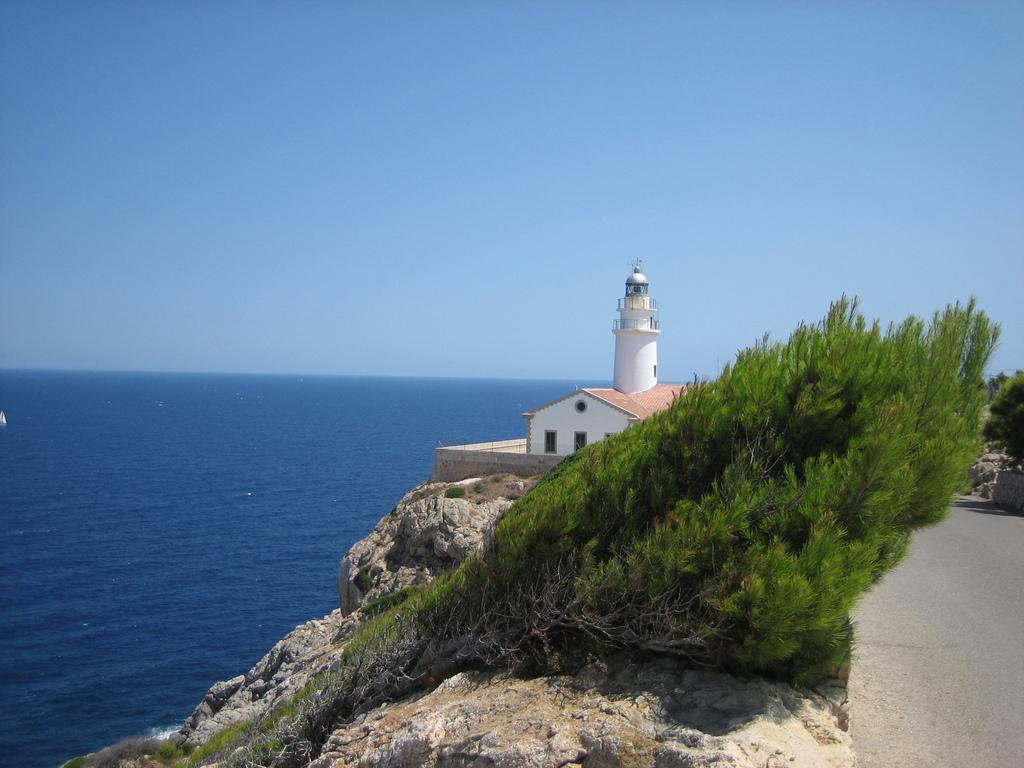In one or two sentences, can you explain what this image depicts? Here in this picture, in the middle we can see a house and a lighthouse present over a place and in the front we can see plants and trees present on the ground and we can see rock stones present and we can see water present all over there and we can see the sky is clear. 